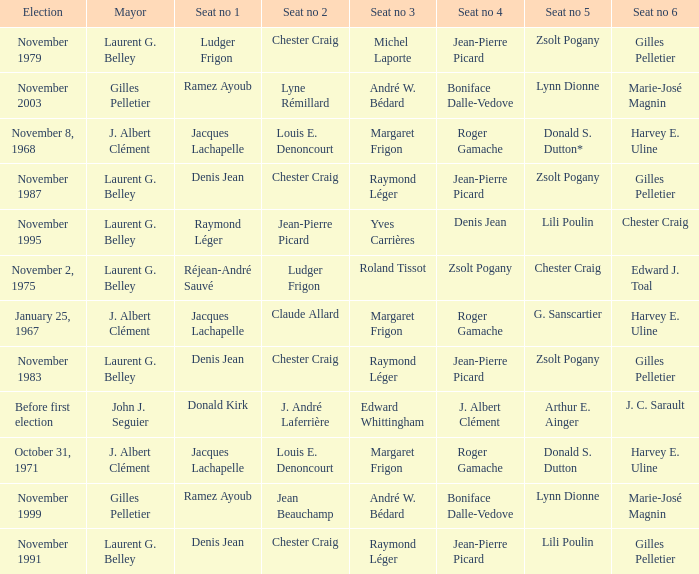Which election had seat no 1 filled by jacques lachapelle but seat no 5 was filled by g. sanscartier January 25, 1967. 